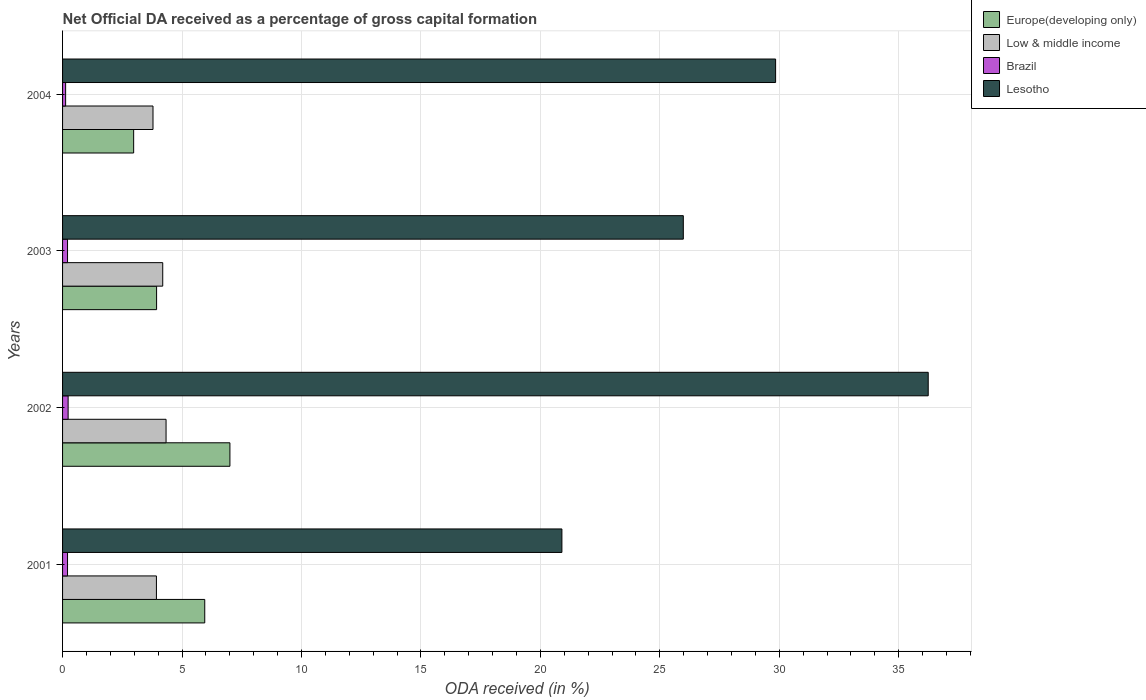In how many cases, is the number of bars for a given year not equal to the number of legend labels?
Keep it short and to the point. 0. What is the net ODA received in Low & middle income in 2001?
Your answer should be very brief. 3.93. Across all years, what is the maximum net ODA received in Europe(developing only)?
Offer a terse response. 7.01. Across all years, what is the minimum net ODA received in Lesotho?
Your answer should be compact. 20.9. In which year was the net ODA received in Brazil maximum?
Provide a succinct answer. 2002. In which year was the net ODA received in Low & middle income minimum?
Your response must be concise. 2004. What is the total net ODA received in Europe(developing only) in the graph?
Provide a succinct answer. 19.87. What is the difference between the net ODA received in Europe(developing only) in 2002 and that in 2004?
Ensure brevity in your answer.  4.03. What is the difference between the net ODA received in Europe(developing only) in 2003 and the net ODA received in Lesotho in 2002?
Your answer should be compact. -32.3. What is the average net ODA received in Brazil per year?
Make the answer very short. 0.19. In the year 2001, what is the difference between the net ODA received in Low & middle income and net ODA received in Europe(developing only)?
Ensure brevity in your answer.  -2.02. What is the ratio of the net ODA received in Europe(developing only) in 2001 to that in 2003?
Give a very brief answer. 1.51. Is the net ODA received in Lesotho in 2001 less than that in 2004?
Provide a short and direct response. Yes. Is the difference between the net ODA received in Low & middle income in 2001 and 2003 greater than the difference between the net ODA received in Europe(developing only) in 2001 and 2003?
Provide a short and direct response. No. What is the difference between the highest and the second highest net ODA received in Europe(developing only)?
Provide a short and direct response. 1.05. What is the difference between the highest and the lowest net ODA received in Europe(developing only)?
Your response must be concise. 4.03. Is it the case that in every year, the sum of the net ODA received in Low & middle income and net ODA received in Lesotho is greater than the sum of net ODA received in Europe(developing only) and net ODA received in Brazil?
Provide a succinct answer. Yes. What does the 2nd bar from the top in 2002 represents?
Your answer should be compact. Brazil. What does the 3rd bar from the bottom in 2002 represents?
Give a very brief answer. Brazil. How many years are there in the graph?
Give a very brief answer. 4. What is the difference between two consecutive major ticks on the X-axis?
Offer a very short reply. 5. Are the values on the major ticks of X-axis written in scientific E-notation?
Offer a very short reply. No. Does the graph contain grids?
Provide a succinct answer. Yes. Where does the legend appear in the graph?
Offer a terse response. Top right. How many legend labels are there?
Ensure brevity in your answer.  4. How are the legend labels stacked?
Provide a succinct answer. Vertical. What is the title of the graph?
Your response must be concise. Net Official DA received as a percentage of gross capital formation. Does "Turkmenistan" appear as one of the legend labels in the graph?
Your answer should be very brief. No. What is the label or title of the X-axis?
Make the answer very short. ODA received (in %). What is the label or title of the Y-axis?
Your response must be concise. Years. What is the ODA received (in %) of Europe(developing only) in 2001?
Ensure brevity in your answer.  5.95. What is the ODA received (in %) in Low & middle income in 2001?
Ensure brevity in your answer.  3.93. What is the ODA received (in %) of Brazil in 2001?
Offer a very short reply. 0.21. What is the ODA received (in %) of Lesotho in 2001?
Offer a very short reply. 20.9. What is the ODA received (in %) in Europe(developing only) in 2002?
Give a very brief answer. 7.01. What is the ODA received (in %) in Low & middle income in 2002?
Your response must be concise. 4.33. What is the ODA received (in %) in Brazil in 2002?
Provide a short and direct response. 0.23. What is the ODA received (in %) of Lesotho in 2002?
Your response must be concise. 36.24. What is the ODA received (in %) in Europe(developing only) in 2003?
Your response must be concise. 3.94. What is the ODA received (in %) in Low & middle income in 2003?
Your response must be concise. 4.19. What is the ODA received (in %) in Brazil in 2003?
Make the answer very short. 0.21. What is the ODA received (in %) of Lesotho in 2003?
Give a very brief answer. 25.99. What is the ODA received (in %) in Europe(developing only) in 2004?
Offer a terse response. 2.98. What is the ODA received (in %) of Low & middle income in 2004?
Provide a short and direct response. 3.79. What is the ODA received (in %) in Brazil in 2004?
Give a very brief answer. 0.13. What is the ODA received (in %) of Lesotho in 2004?
Your answer should be very brief. 29.85. Across all years, what is the maximum ODA received (in %) in Europe(developing only)?
Your answer should be very brief. 7.01. Across all years, what is the maximum ODA received (in %) of Low & middle income?
Your answer should be very brief. 4.33. Across all years, what is the maximum ODA received (in %) of Brazil?
Your answer should be compact. 0.23. Across all years, what is the maximum ODA received (in %) in Lesotho?
Give a very brief answer. 36.24. Across all years, what is the minimum ODA received (in %) in Europe(developing only)?
Offer a terse response. 2.98. Across all years, what is the minimum ODA received (in %) in Low & middle income?
Provide a succinct answer. 3.79. Across all years, what is the minimum ODA received (in %) in Brazil?
Offer a terse response. 0.13. Across all years, what is the minimum ODA received (in %) in Lesotho?
Offer a terse response. 20.9. What is the total ODA received (in %) of Europe(developing only) in the graph?
Offer a very short reply. 19.87. What is the total ODA received (in %) of Low & middle income in the graph?
Your response must be concise. 16.24. What is the total ODA received (in %) in Brazil in the graph?
Offer a very short reply. 0.78. What is the total ODA received (in %) of Lesotho in the graph?
Give a very brief answer. 112.97. What is the difference between the ODA received (in %) of Europe(developing only) in 2001 and that in 2002?
Offer a very short reply. -1.05. What is the difference between the ODA received (in %) of Low & middle income in 2001 and that in 2002?
Ensure brevity in your answer.  -0.4. What is the difference between the ODA received (in %) in Brazil in 2001 and that in 2002?
Offer a very short reply. -0.02. What is the difference between the ODA received (in %) of Lesotho in 2001 and that in 2002?
Ensure brevity in your answer.  -15.33. What is the difference between the ODA received (in %) of Europe(developing only) in 2001 and that in 2003?
Ensure brevity in your answer.  2.02. What is the difference between the ODA received (in %) in Low & middle income in 2001 and that in 2003?
Offer a very short reply. -0.26. What is the difference between the ODA received (in %) in Brazil in 2001 and that in 2003?
Your answer should be compact. -0. What is the difference between the ODA received (in %) in Lesotho in 2001 and that in 2003?
Your answer should be compact. -5.08. What is the difference between the ODA received (in %) in Europe(developing only) in 2001 and that in 2004?
Give a very brief answer. 2.98. What is the difference between the ODA received (in %) in Low & middle income in 2001 and that in 2004?
Your response must be concise. 0.14. What is the difference between the ODA received (in %) of Brazil in 2001 and that in 2004?
Your answer should be compact. 0.08. What is the difference between the ODA received (in %) of Lesotho in 2001 and that in 2004?
Offer a terse response. -8.95. What is the difference between the ODA received (in %) of Europe(developing only) in 2002 and that in 2003?
Give a very brief answer. 3.07. What is the difference between the ODA received (in %) of Low & middle income in 2002 and that in 2003?
Keep it short and to the point. 0.14. What is the difference between the ODA received (in %) of Brazil in 2002 and that in 2003?
Give a very brief answer. 0.02. What is the difference between the ODA received (in %) in Lesotho in 2002 and that in 2003?
Offer a very short reply. 10.25. What is the difference between the ODA received (in %) in Europe(developing only) in 2002 and that in 2004?
Make the answer very short. 4.03. What is the difference between the ODA received (in %) of Low & middle income in 2002 and that in 2004?
Give a very brief answer. 0.55. What is the difference between the ODA received (in %) in Brazil in 2002 and that in 2004?
Your answer should be compact. 0.1. What is the difference between the ODA received (in %) of Lesotho in 2002 and that in 2004?
Keep it short and to the point. 6.39. What is the difference between the ODA received (in %) in Europe(developing only) in 2003 and that in 2004?
Offer a very short reply. 0.96. What is the difference between the ODA received (in %) in Low & middle income in 2003 and that in 2004?
Provide a short and direct response. 0.41. What is the difference between the ODA received (in %) of Brazil in 2003 and that in 2004?
Provide a succinct answer. 0.08. What is the difference between the ODA received (in %) of Lesotho in 2003 and that in 2004?
Offer a very short reply. -3.86. What is the difference between the ODA received (in %) of Europe(developing only) in 2001 and the ODA received (in %) of Low & middle income in 2002?
Ensure brevity in your answer.  1.62. What is the difference between the ODA received (in %) of Europe(developing only) in 2001 and the ODA received (in %) of Brazil in 2002?
Make the answer very short. 5.72. What is the difference between the ODA received (in %) in Europe(developing only) in 2001 and the ODA received (in %) in Lesotho in 2002?
Keep it short and to the point. -30.29. What is the difference between the ODA received (in %) in Low & middle income in 2001 and the ODA received (in %) in Brazil in 2002?
Offer a terse response. 3.7. What is the difference between the ODA received (in %) in Low & middle income in 2001 and the ODA received (in %) in Lesotho in 2002?
Provide a short and direct response. -32.31. What is the difference between the ODA received (in %) in Brazil in 2001 and the ODA received (in %) in Lesotho in 2002?
Your answer should be compact. -36.03. What is the difference between the ODA received (in %) of Europe(developing only) in 2001 and the ODA received (in %) of Low & middle income in 2003?
Make the answer very short. 1.76. What is the difference between the ODA received (in %) of Europe(developing only) in 2001 and the ODA received (in %) of Brazil in 2003?
Provide a succinct answer. 5.74. What is the difference between the ODA received (in %) of Europe(developing only) in 2001 and the ODA received (in %) of Lesotho in 2003?
Give a very brief answer. -20.03. What is the difference between the ODA received (in %) in Low & middle income in 2001 and the ODA received (in %) in Brazil in 2003?
Offer a terse response. 3.72. What is the difference between the ODA received (in %) in Low & middle income in 2001 and the ODA received (in %) in Lesotho in 2003?
Ensure brevity in your answer.  -22.06. What is the difference between the ODA received (in %) of Brazil in 2001 and the ODA received (in %) of Lesotho in 2003?
Offer a very short reply. -25.78. What is the difference between the ODA received (in %) of Europe(developing only) in 2001 and the ODA received (in %) of Low & middle income in 2004?
Make the answer very short. 2.17. What is the difference between the ODA received (in %) in Europe(developing only) in 2001 and the ODA received (in %) in Brazil in 2004?
Your response must be concise. 5.82. What is the difference between the ODA received (in %) of Europe(developing only) in 2001 and the ODA received (in %) of Lesotho in 2004?
Offer a very short reply. -23.9. What is the difference between the ODA received (in %) in Low & middle income in 2001 and the ODA received (in %) in Brazil in 2004?
Make the answer very short. 3.8. What is the difference between the ODA received (in %) in Low & middle income in 2001 and the ODA received (in %) in Lesotho in 2004?
Offer a very short reply. -25.92. What is the difference between the ODA received (in %) of Brazil in 2001 and the ODA received (in %) of Lesotho in 2004?
Provide a succinct answer. -29.64. What is the difference between the ODA received (in %) in Europe(developing only) in 2002 and the ODA received (in %) in Low & middle income in 2003?
Offer a very short reply. 2.81. What is the difference between the ODA received (in %) in Europe(developing only) in 2002 and the ODA received (in %) in Brazil in 2003?
Give a very brief answer. 6.8. What is the difference between the ODA received (in %) in Europe(developing only) in 2002 and the ODA received (in %) in Lesotho in 2003?
Ensure brevity in your answer.  -18.98. What is the difference between the ODA received (in %) in Low & middle income in 2002 and the ODA received (in %) in Brazil in 2003?
Keep it short and to the point. 4.12. What is the difference between the ODA received (in %) of Low & middle income in 2002 and the ODA received (in %) of Lesotho in 2003?
Offer a terse response. -21.65. What is the difference between the ODA received (in %) of Brazil in 2002 and the ODA received (in %) of Lesotho in 2003?
Make the answer very short. -25.75. What is the difference between the ODA received (in %) in Europe(developing only) in 2002 and the ODA received (in %) in Low & middle income in 2004?
Provide a short and direct response. 3.22. What is the difference between the ODA received (in %) of Europe(developing only) in 2002 and the ODA received (in %) of Brazil in 2004?
Ensure brevity in your answer.  6.88. What is the difference between the ODA received (in %) in Europe(developing only) in 2002 and the ODA received (in %) in Lesotho in 2004?
Keep it short and to the point. -22.84. What is the difference between the ODA received (in %) of Low & middle income in 2002 and the ODA received (in %) of Brazil in 2004?
Provide a succinct answer. 4.2. What is the difference between the ODA received (in %) in Low & middle income in 2002 and the ODA received (in %) in Lesotho in 2004?
Give a very brief answer. -25.52. What is the difference between the ODA received (in %) in Brazil in 2002 and the ODA received (in %) in Lesotho in 2004?
Keep it short and to the point. -29.62. What is the difference between the ODA received (in %) of Europe(developing only) in 2003 and the ODA received (in %) of Low & middle income in 2004?
Provide a short and direct response. 0.15. What is the difference between the ODA received (in %) of Europe(developing only) in 2003 and the ODA received (in %) of Brazil in 2004?
Give a very brief answer. 3.81. What is the difference between the ODA received (in %) in Europe(developing only) in 2003 and the ODA received (in %) in Lesotho in 2004?
Offer a terse response. -25.91. What is the difference between the ODA received (in %) in Low & middle income in 2003 and the ODA received (in %) in Brazil in 2004?
Your answer should be compact. 4.07. What is the difference between the ODA received (in %) of Low & middle income in 2003 and the ODA received (in %) of Lesotho in 2004?
Keep it short and to the point. -25.66. What is the difference between the ODA received (in %) of Brazil in 2003 and the ODA received (in %) of Lesotho in 2004?
Provide a short and direct response. -29.64. What is the average ODA received (in %) in Europe(developing only) per year?
Offer a terse response. 4.97. What is the average ODA received (in %) of Low & middle income per year?
Your response must be concise. 4.06. What is the average ODA received (in %) of Brazil per year?
Your response must be concise. 0.19. What is the average ODA received (in %) of Lesotho per year?
Provide a succinct answer. 28.24. In the year 2001, what is the difference between the ODA received (in %) in Europe(developing only) and ODA received (in %) in Low & middle income?
Your response must be concise. 2.02. In the year 2001, what is the difference between the ODA received (in %) in Europe(developing only) and ODA received (in %) in Brazil?
Keep it short and to the point. 5.74. In the year 2001, what is the difference between the ODA received (in %) of Europe(developing only) and ODA received (in %) of Lesotho?
Your response must be concise. -14.95. In the year 2001, what is the difference between the ODA received (in %) in Low & middle income and ODA received (in %) in Brazil?
Your answer should be very brief. 3.72. In the year 2001, what is the difference between the ODA received (in %) of Low & middle income and ODA received (in %) of Lesotho?
Your answer should be very brief. -16.97. In the year 2001, what is the difference between the ODA received (in %) of Brazil and ODA received (in %) of Lesotho?
Offer a terse response. -20.7. In the year 2002, what is the difference between the ODA received (in %) of Europe(developing only) and ODA received (in %) of Low & middle income?
Your answer should be very brief. 2.67. In the year 2002, what is the difference between the ODA received (in %) of Europe(developing only) and ODA received (in %) of Brazil?
Ensure brevity in your answer.  6.77. In the year 2002, what is the difference between the ODA received (in %) of Europe(developing only) and ODA received (in %) of Lesotho?
Make the answer very short. -29.23. In the year 2002, what is the difference between the ODA received (in %) in Low & middle income and ODA received (in %) in Brazil?
Provide a succinct answer. 4.1. In the year 2002, what is the difference between the ODA received (in %) of Low & middle income and ODA received (in %) of Lesotho?
Provide a succinct answer. -31.9. In the year 2002, what is the difference between the ODA received (in %) in Brazil and ODA received (in %) in Lesotho?
Ensure brevity in your answer.  -36. In the year 2003, what is the difference between the ODA received (in %) of Europe(developing only) and ODA received (in %) of Low & middle income?
Give a very brief answer. -0.26. In the year 2003, what is the difference between the ODA received (in %) of Europe(developing only) and ODA received (in %) of Brazil?
Your response must be concise. 3.73. In the year 2003, what is the difference between the ODA received (in %) of Europe(developing only) and ODA received (in %) of Lesotho?
Your response must be concise. -22.05. In the year 2003, what is the difference between the ODA received (in %) in Low & middle income and ODA received (in %) in Brazil?
Your response must be concise. 3.99. In the year 2003, what is the difference between the ODA received (in %) in Low & middle income and ODA received (in %) in Lesotho?
Ensure brevity in your answer.  -21.79. In the year 2003, what is the difference between the ODA received (in %) of Brazil and ODA received (in %) of Lesotho?
Provide a succinct answer. -25.78. In the year 2004, what is the difference between the ODA received (in %) in Europe(developing only) and ODA received (in %) in Low & middle income?
Your response must be concise. -0.81. In the year 2004, what is the difference between the ODA received (in %) of Europe(developing only) and ODA received (in %) of Brazil?
Make the answer very short. 2.85. In the year 2004, what is the difference between the ODA received (in %) in Europe(developing only) and ODA received (in %) in Lesotho?
Your answer should be very brief. -26.87. In the year 2004, what is the difference between the ODA received (in %) in Low & middle income and ODA received (in %) in Brazil?
Offer a terse response. 3.66. In the year 2004, what is the difference between the ODA received (in %) of Low & middle income and ODA received (in %) of Lesotho?
Make the answer very short. -26.06. In the year 2004, what is the difference between the ODA received (in %) of Brazil and ODA received (in %) of Lesotho?
Keep it short and to the point. -29.72. What is the ratio of the ODA received (in %) of Europe(developing only) in 2001 to that in 2002?
Ensure brevity in your answer.  0.85. What is the ratio of the ODA received (in %) of Low & middle income in 2001 to that in 2002?
Provide a short and direct response. 0.91. What is the ratio of the ODA received (in %) of Brazil in 2001 to that in 2002?
Provide a short and direct response. 0.89. What is the ratio of the ODA received (in %) of Lesotho in 2001 to that in 2002?
Make the answer very short. 0.58. What is the ratio of the ODA received (in %) in Europe(developing only) in 2001 to that in 2003?
Make the answer very short. 1.51. What is the ratio of the ODA received (in %) in Low & middle income in 2001 to that in 2003?
Ensure brevity in your answer.  0.94. What is the ratio of the ODA received (in %) of Brazil in 2001 to that in 2003?
Provide a short and direct response. 1. What is the ratio of the ODA received (in %) in Lesotho in 2001 to that in 2003?
Give a very brief answer. 0.8. What is the ratio of the ODA received (in %) in Europe(developing only) in 2001 to that in 2004?
Offer a very short reply. 2. What is the ratio of the ODA received (in %) of Low & middle income in 2001 to that in 2004?
Your answer should be compact. 1.04. What is the ratio of the ODA received (in %) of Brazil in 2001 to that in 2004?
Your answer should be compact. 1.63. What is the ratio of the ODA received (in %) in Lesotho in 2001 to that in 2004?
Make the answer very short. 0.7. What is the ratio of the ODA received (in %) of Europe(developing only) in 2002 to that in 2003?
Keep it short and to the point. 1.78. What is the ratio of the ODA received (in %) of Low & middle income in 2002 to that in 2003?
Make the answer very short. 1.03. What is the ratio of the ODA received (in %) in Brazil in 2002 to that in 2003?
Your response must be concise. 1.12. What is the ratio of the ODA received (in %) in Lesotho in 2002 to that in 2003?
Provide a short and direct response. 1.39. What is the ratio of the ODA received (in %) in Europe(developing only) in 2002 to that in 2004?
Your answer should be compact. 2.35. What is the ratio of the ODA received (in %) of Low & middle income in 2002 to that in 2004?
Ensure brevity in your answer.  1.14. What is the ratio of the ODA received (in %) in Brazil in 2002 to that in 2004?
Give a very brief answer. 1.82. What is the ratio of the ODA received (in %) of Lesotho in 2002 to that in 2004?
Your response must be concise. 1.21. What is the ratio of the ODA received (in %) of Europe(developing only) in 2003 to that in 2004?
Provide a succinct answer. 1.32. What is the ratio of the ODA received (in %) of Low & middle income in 2003 to that in 2004?
Your answer should be compact. 1.11. What is the ratio of the ODA received (in %) in Brazil in 2003 to that in 2004?
Ensure brevity in your answer.  1.63. What is the ratio of the ODA received (in %) in Lesotho in 2003 to that in 2004?
Offer a very short reply. 0.87. What is the difference between the highest and the second highest ODA received (in %) in Europe(developing only)?
Provide a succinct answer. 1.05. What is the difference between the highest and the second highest ODA received (in %) of Low & middle income?
Offer a very short reply. 0.14. What is the difference between the highest and the second highest ODA received (in %) in Brazil?
Your answer should be very brief. 0.02. What is the difference between the highest and the second highest ODA received (in %) in Lesotho?
Provide a short and direct response. 6.39. What is the difference between the highest and the lowest ODA received (in %) of Europe(developing only)?
Offer a terse response. 4.03. What is the difference between the highest and the lowest ODA received (in %) of Low & middle income?
Make the answer very short. 0.55. What is the difference between the highest and the lowest ODA received (in %) in Brazil?
Provide a succinct answer. 0.1. What is the difference between the highest and the lowest ODA received (in %) in Lesotho?
Ensure brevity in your answer.  15.33. 